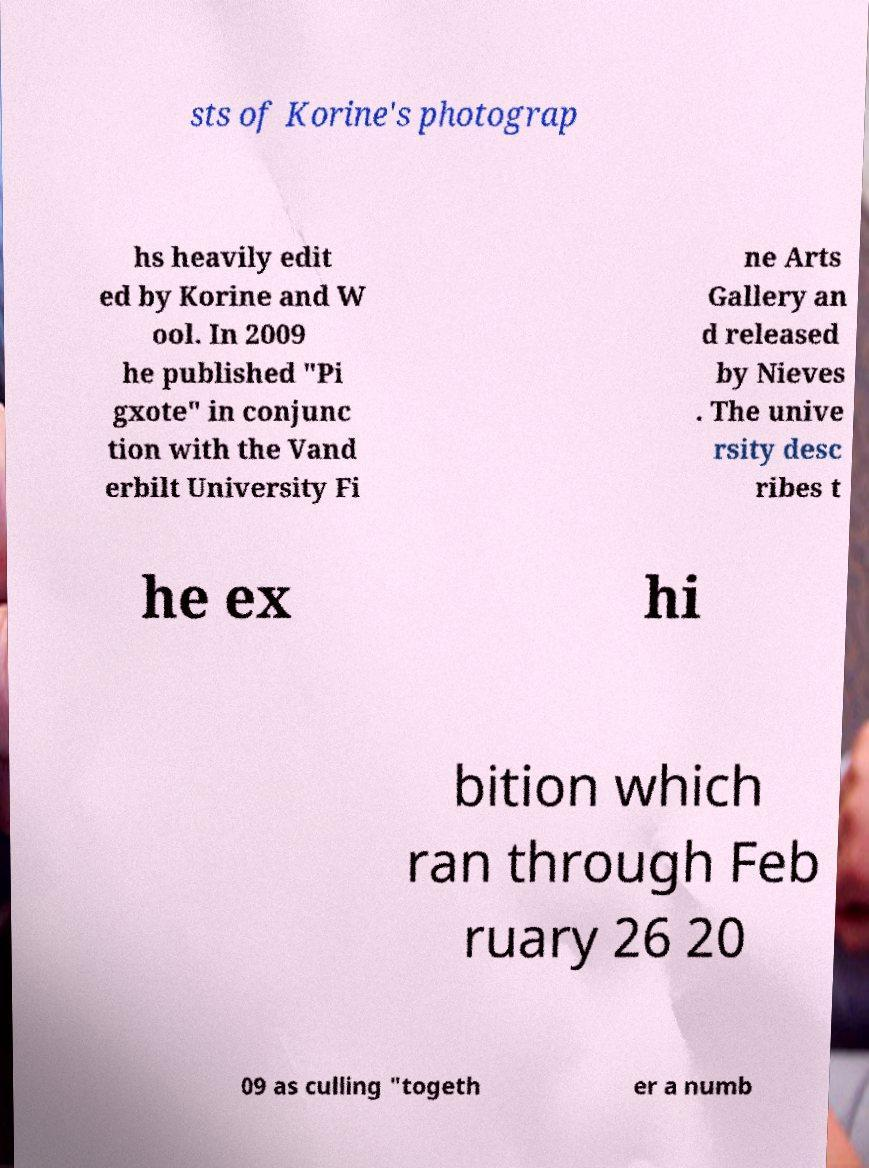Can you accurately transcribe the text from the provided image for me? sts of Korine's photograp hs heavily edit ed by Korine and W ool. In 2009 he published "Pi gxote" in conjunc tion with the Vand erbilt University Fi ne Arts Gallery an d released by Nieves . The unive rsity desc ribes t he ex hi bition which ran through Feb ruary 26 20 09 as culling "togeth er a numb 